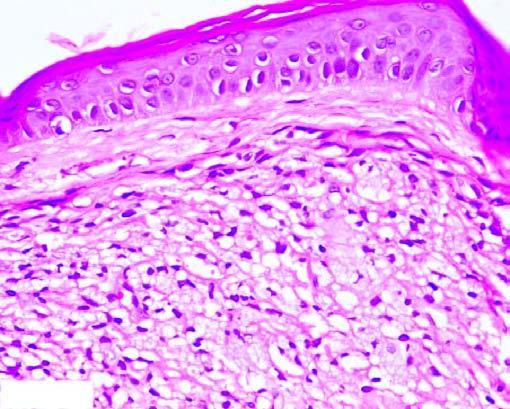what is there in the dermis with a clear subepidermal zone?
Answer the question using a single word or phrase. Collection of proliferating foam macrophages 